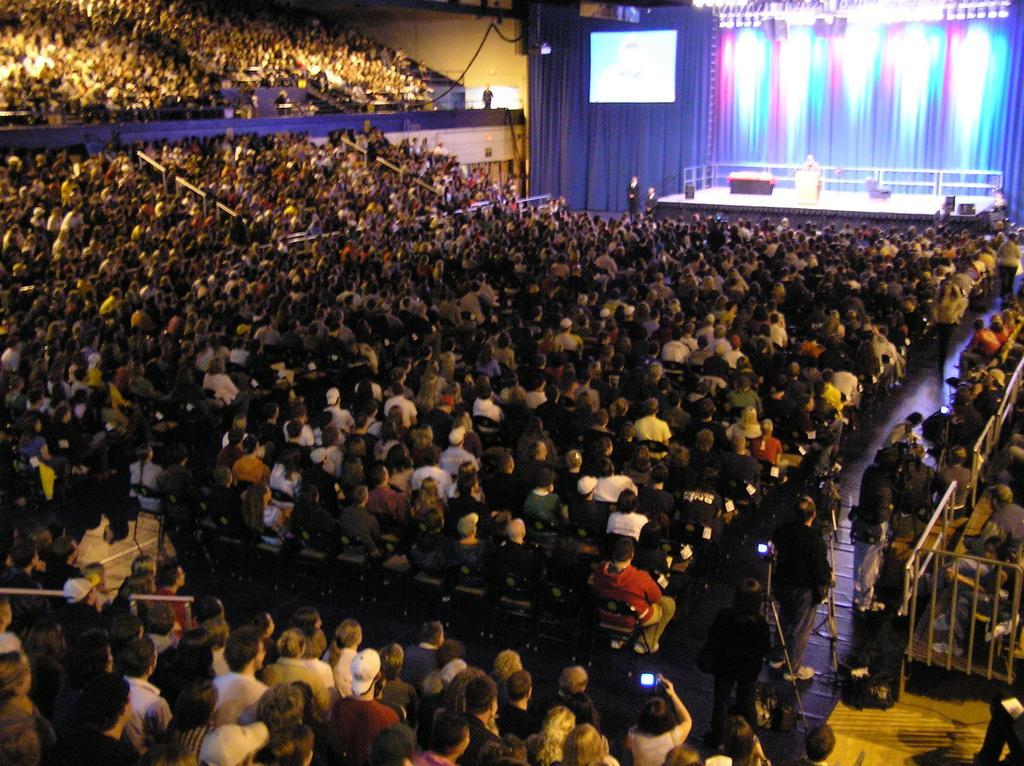Can you describe this image briefly? In this picture we can see a group of people are sitting in the auditorium. On the right side of the image we can see the grilles, floor, cameras with stand. At the top of the image we can see the curtain, screen, stage, grilles, lights, wall. On the stage we can see a table, light, podium and a person is standing in-front of podium. 